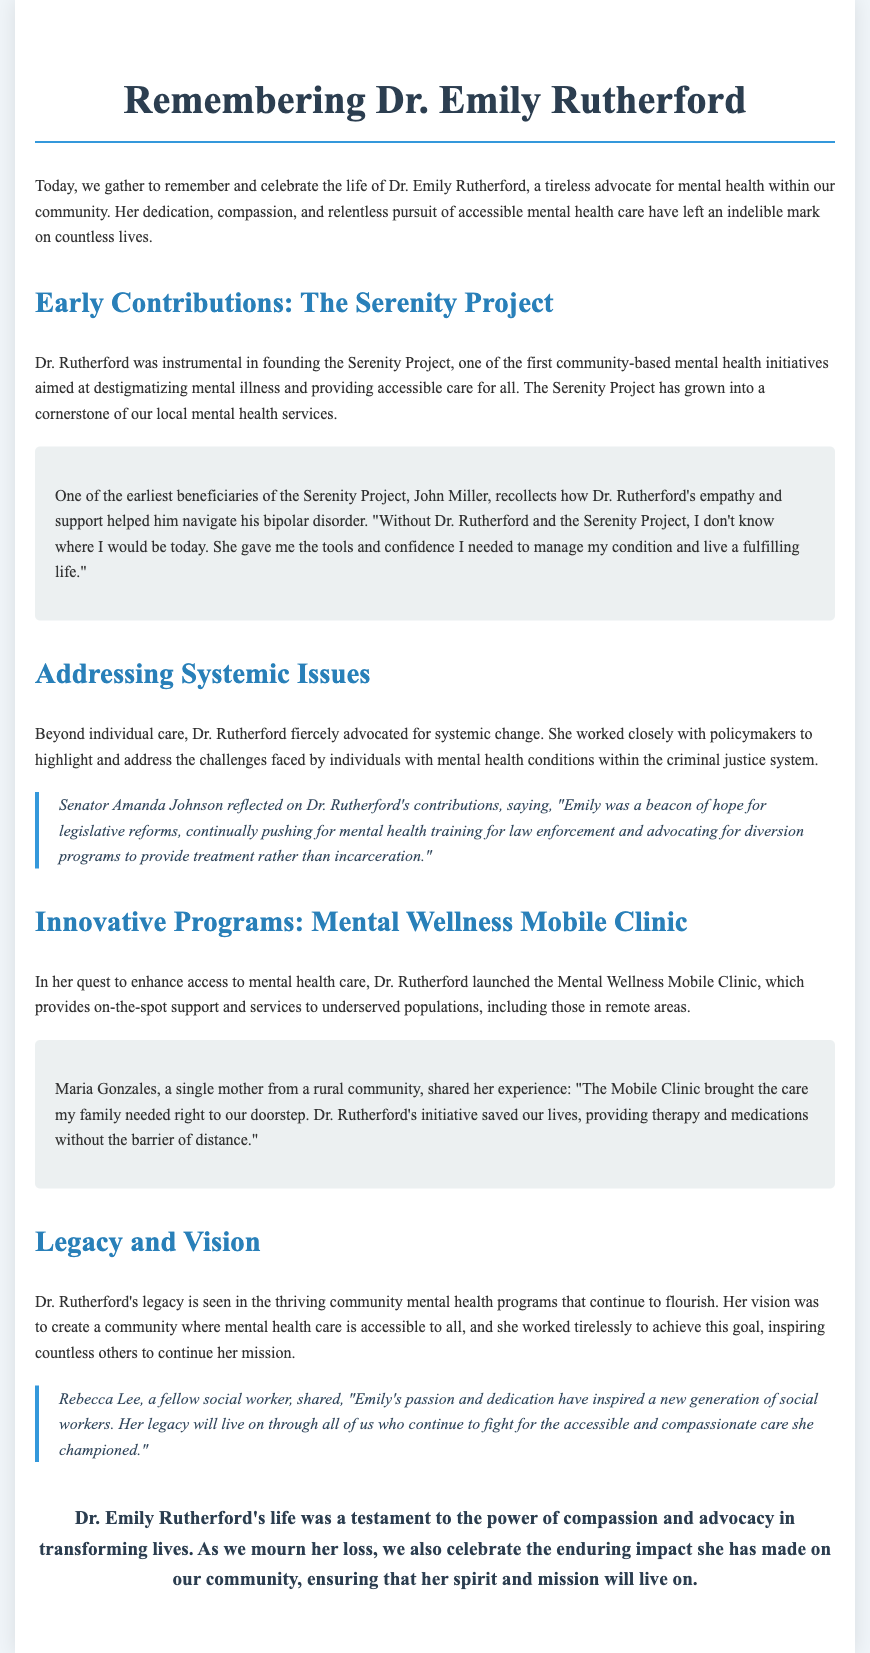What was the name of the project Dr. Rutherford founded? The document mentions that Dr. Rutherford was instrumental in founding the Serenity Project, which aimed to destigmatize mental illness and provide accessible care.
Answer: Serenity Project Who is one individual that benefited from the Serenity Project? The document references John Miller as an early beneficiary of the Serenity Project who shared his positive experience.
Answer: John Miller What was Dr. Rutherford's role in addressing mental health within the criminal justice system? The document states that Dr. Rutherford advocated for systemic change and worked with policymakers on challenges faced by individuals with mental health conditions in the criminal justice system.
Answer: Advocate What initiative did Dr. Rutherford launch to enhance access to mental health care? The document describes the Mental Wellness Mobile Clinic as the initiative launched by Dr. Rutherford to provide on-the-spot support to underserved populations.
Answer: Mental Wellness Mobile Clinic What did Senator Amanda Johnson call Dr. Rutherford? According to the document, Senator Amanda Johnson referred to Dr. Rutherford as a "beacon of hope" in her quote about legislative reforms in mental health.
Answer: Beacon of hope What did Maria Gonzales call the impact of the Mobile Clinic on her family? The document includes Maria Gonzales stating that the Mobile Clinic "saved our lives" by providing necessary therapy and medications.
Answer: Saved our lives Which aspect of Dr. Rutherford's legacy is highlighted in the document? The document emphasizes that Dr. Rutherford's legacy is seen in the thriving community mental health programs that continue to flourish and her inspiration to others.
Answer: Thriving community mental health programs Who is referred to as a fellow social worker reflecting on Dr. Rutherford's impact? Rebecca Lee is mentioned as a fellow social worker sharing insights about Dr. Rutherford’s passion and dedication.
Answer: Rebecca Lee 